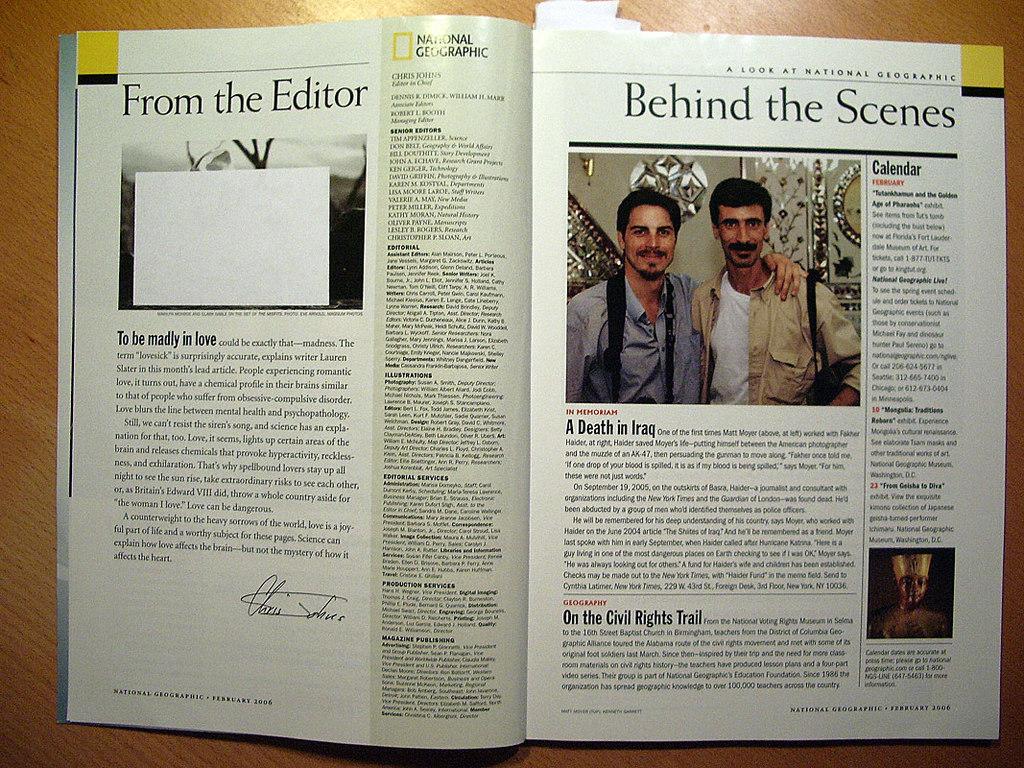What emotion is the editor of the national geographic writing about?
Your answer should be compact. Love. The title of the article on the right is?
Your response must be concise. Behind the scenes. 